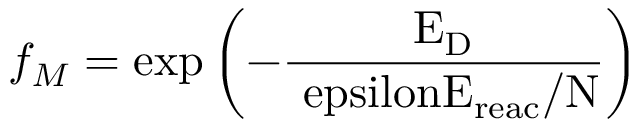Convert formula to latex. <formula><loc_0><loc_0><loc_500><loc_500>f _ { M } = { e x p } \left ( - \frac { E _ { \mathrm { D } } } { \ e p s i l o n E _ { \mathrm { r e a c } } / N } \right )</formula> 